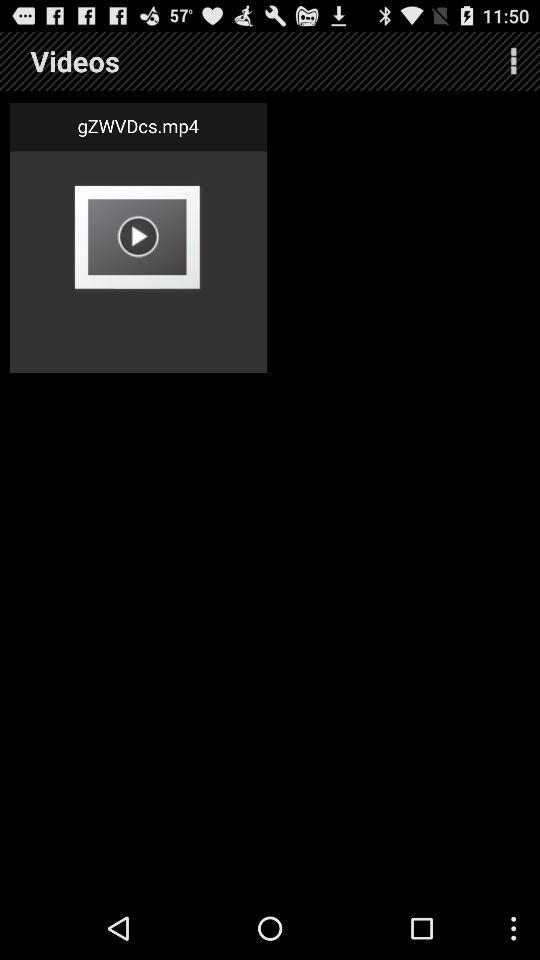What is the name of the video? The name of the video is "gZWVDcs.mp4". 